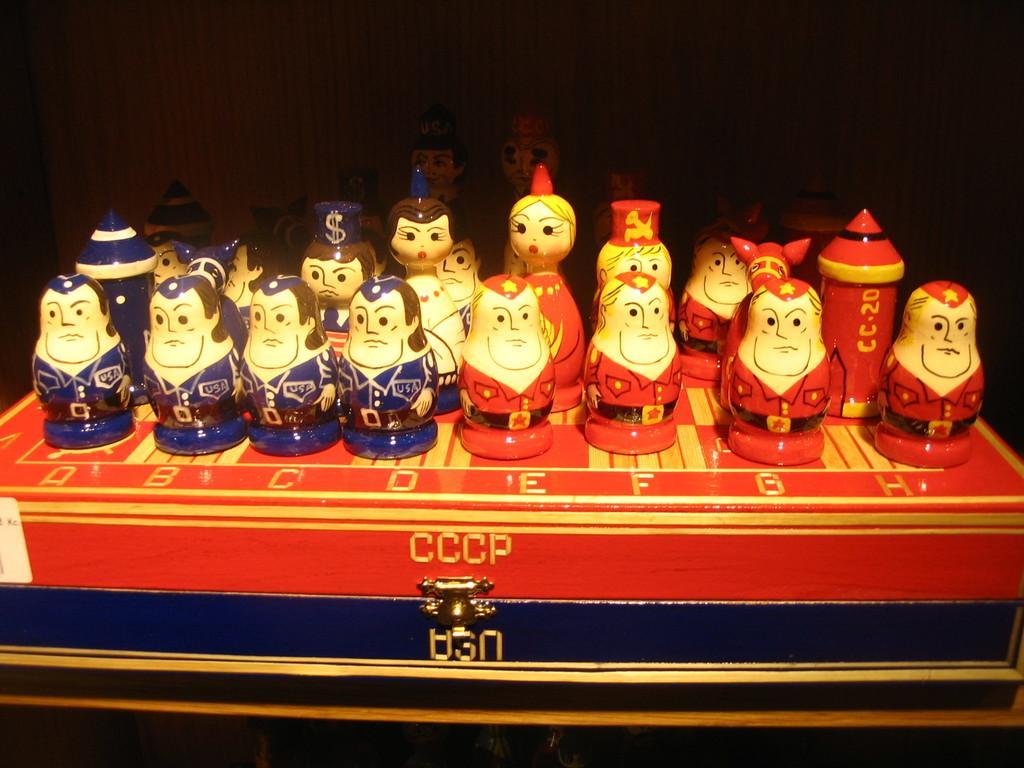Can you describe this image briefly? In this picture we can see some figurines, there is a dark background, it looks like a box at the bottom. 